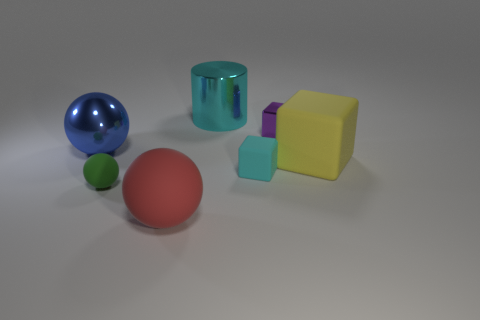The tiny metallic cube has what color?
Offer a very short reply. Purple. Are there any big spheres right of the small green rubber ball?
Your answer should be compact. Yes. Do the large cylinder and the tiny matte sphere have the same color?
Make the answer very short. No. How many shiny blocks are the same color as the large rubber cube?
Keep it short and to the point. 0. What size is the block that is behind the metallic object that is in front of the metal block?
Keep it short and to the point. Small. What shape is the blue metallic object?
Offer a terse response. Sphere. What is the material of the cube that is behind the big blue ball?
Offer a terse response. Metal. There is a block that is behind the ball that is behind the small rubber object that is behind the green object; what color is it?
Make the answer very short. Purple. What color is the metal cube that is the same size as the green rubber object?
Offer a very short reply. Purple. What number of shiny objects are red balls or tiny purple objects?
Keep it short and to the point. 1. 